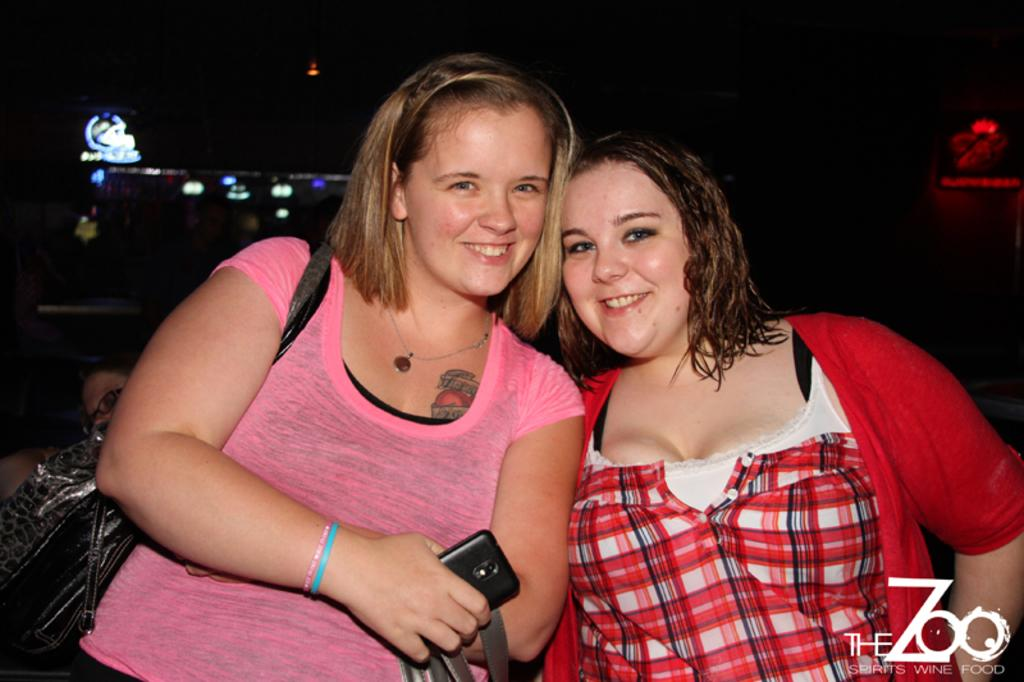What is happening in the image? There are people standing in the image. Can you describe the woman's attire? The woman is wearing a bag. What is the woman holding in her hand? The woman is holding a mobile in her hand. What can be seen in the background of the image? There are lights visible in the background of the image. What type of sea creature can be seen swimming in the image? There is no sea creature present in the image; it features people standing and a woman holding a mobile. 